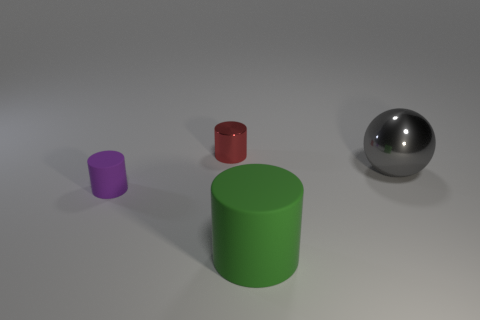Subtract all purple balls. Subtract all cyan cylinders. How many balls are left? 1 Add 3 blue matte blocks. How many objects exist? 7 Subtract all cylinders. How many objects are left? 1 Subtract 0 gray blocks. How many objects are left? 4 Subtract all small things. Subtract all rubber spheres. How many objects are left? 2 Add 3 gray objects. How many gray objects are left? 4 Add 3 tiny objects. How many tiny objects exist? 5 